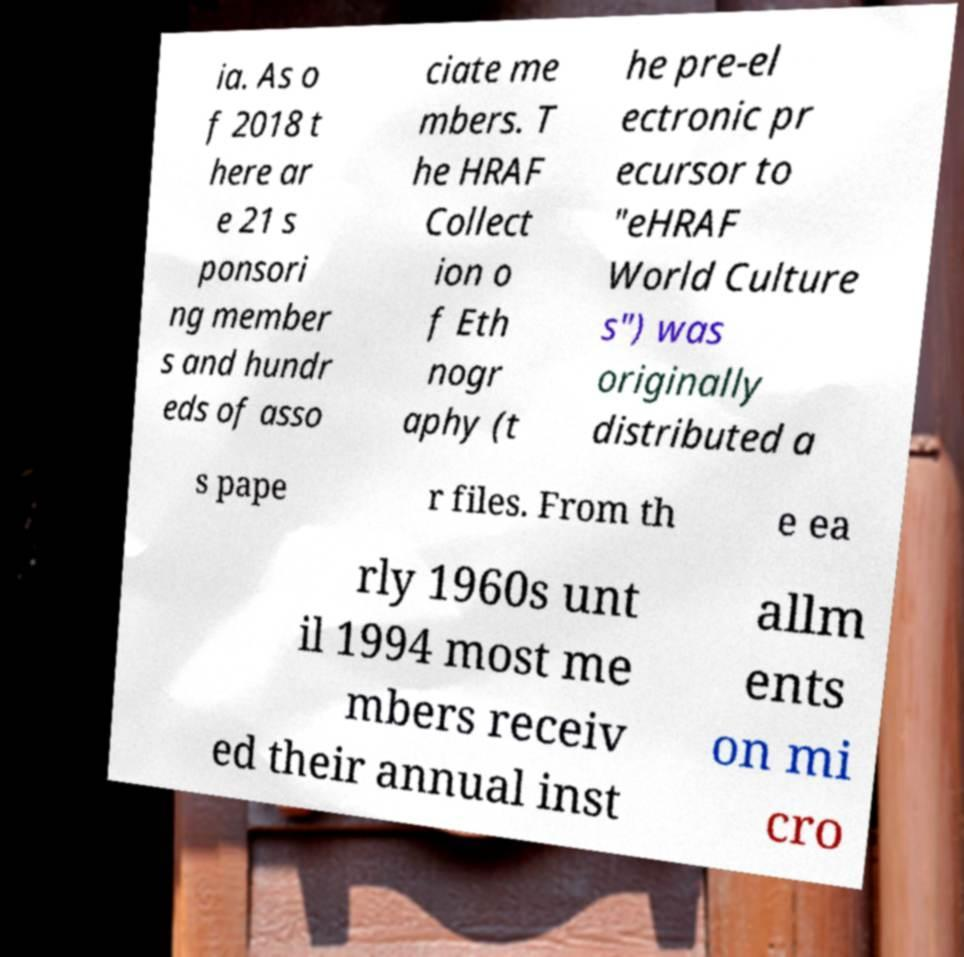What messages or text are displayed in this image? I need them in a readable, typed format. ia. As o f 2018 t here ar e 21 s ponsori ng member s and hundr eds of asso ciate me mbers. T he HRAF Collect ion o f Eth nogr aphy (t he pre-el ectronic pr ecursor to "eHRAF World Culture s") was originally distributed a s pape r files. From th e ea rly 1960s unt il 1994 most me mbers receiv ed their annual inst allm ents on mi cro 